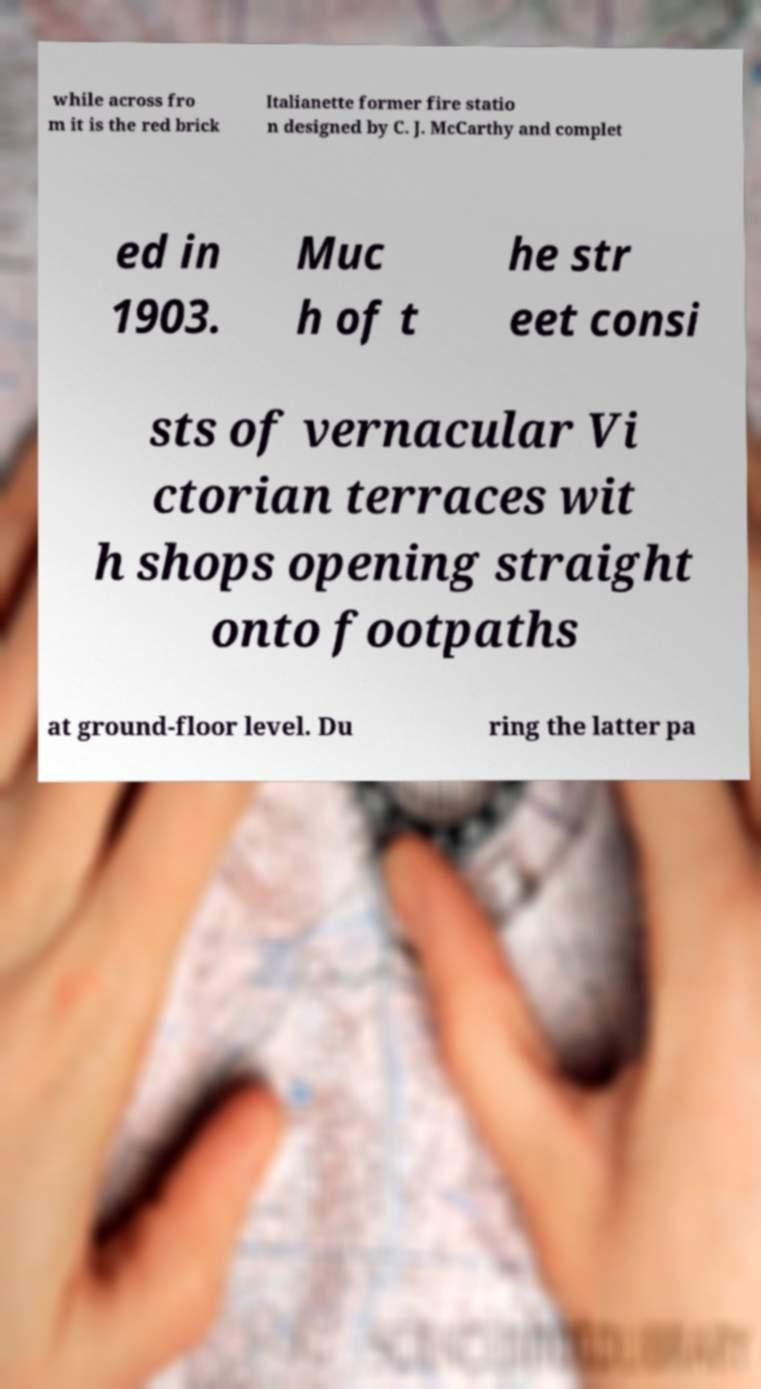For documentation purposes, I need the text within this image transcribed. Could you provide that? while across fro m it is the red brick Italianette former fire statio n designed by C. J. McCarthy and complet ed in 1903. Muc h of t he str eet consi sts of vernacular Vi ctorian terraces wit h shops opening straight onto footpaths at ground-floor level. Du ring the latter pa 